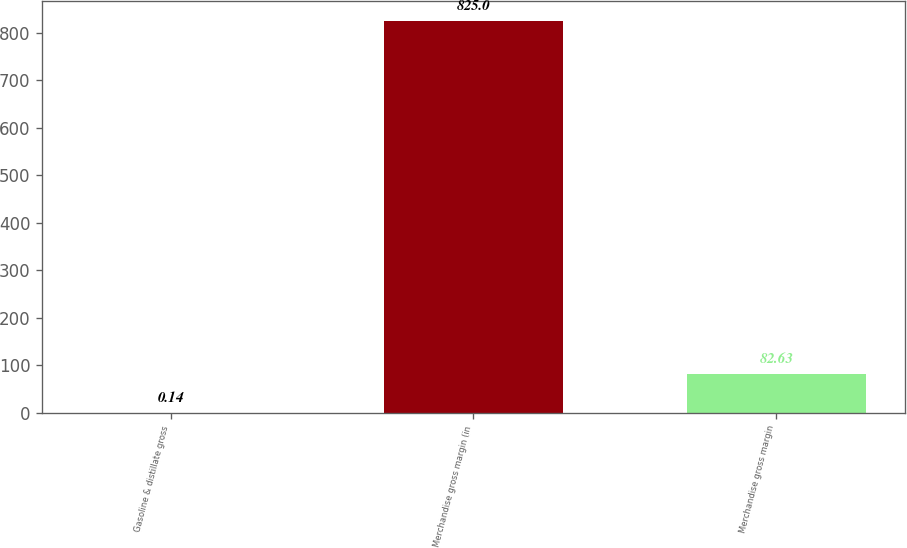<chart> <loc_0><loc_0><loc_500><loc_500><bar_chart><fcel>Gasoline & distillate gross<fcel>Merchandise gross margin (in<fcel>Merchandise gross margin<nl><fcel>0.14<fcel>825<fcel>82.63<nl></chart> 